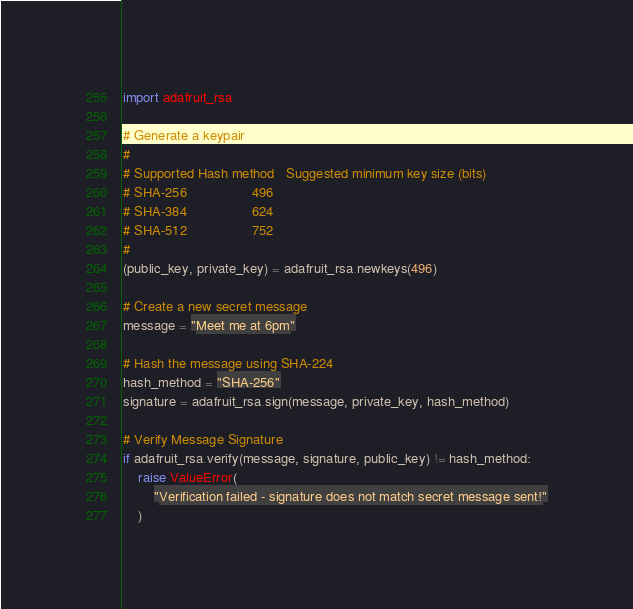<code> <loc_0><loc_0><loc_500><loc_500><_Python_>import adafruit_rsa

# Generate a keypair
#
# Supported Hash method   Suggested minimum key size (bits)
# SHA-256                 496
# SHA-384                 624
# SHA-512                 752
#
(public_key, private_key) = adafruit_rsa.newkeys(496)

# Create a new secret message
message = "Meet me at 6pm"

# Hash the message using SHA-224
hash_method = "SHA-256"
signature = adafruit_rsa.sign(message, private_key, hash_method)

# Verify Message Signature
if adafruit_rsa.verify(message, signature, public_key) != hash_method:
    raise ValueError(
        "Verification failed - signature does not match secret message sent!"
    )
</code> 